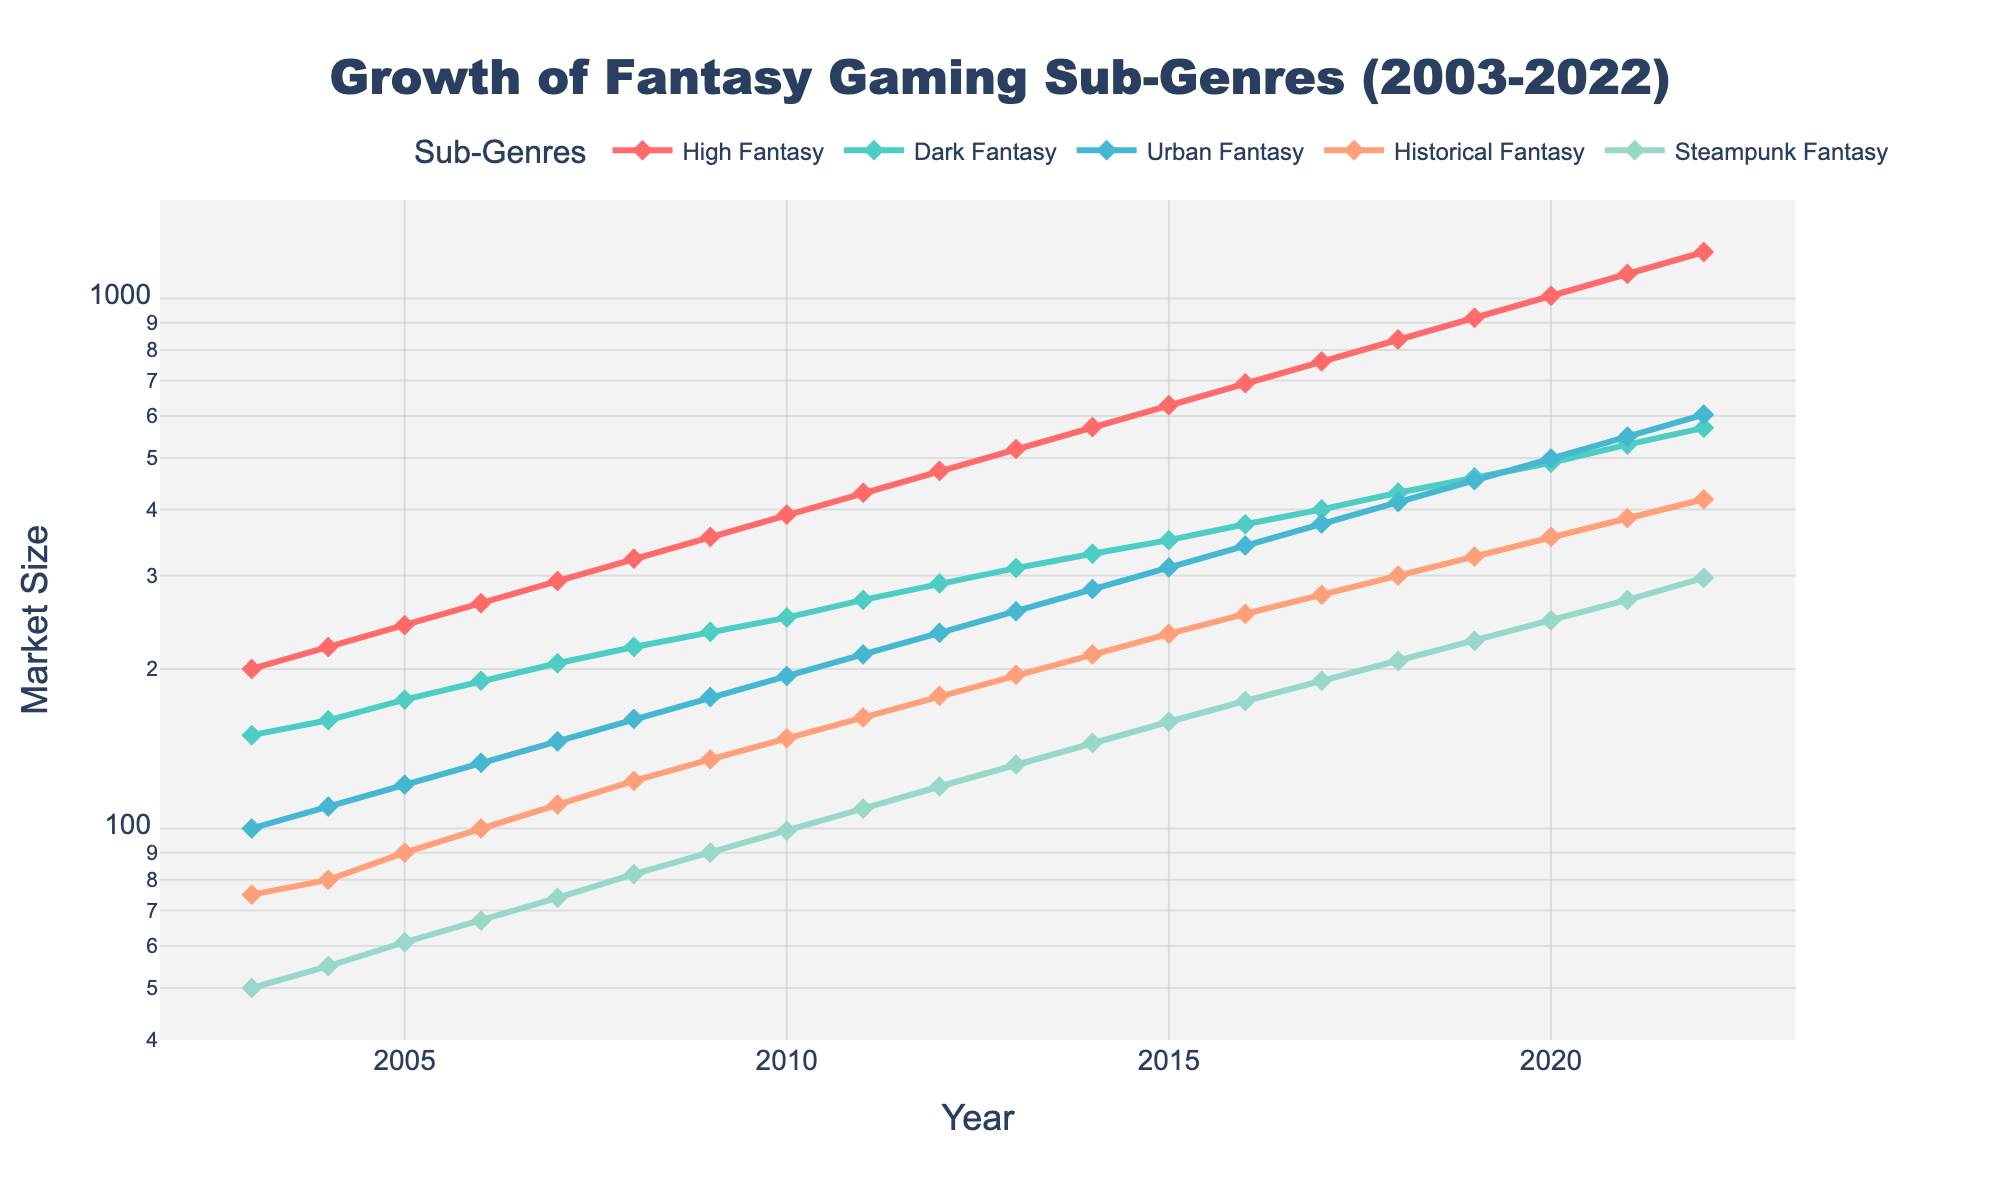What's the title of the plot? The title is located at the top center of the plot. It gives an overview of what the data represents. Here, it clearly states that the plot is about the growth of fantasy gaming sub-genres from 2003 to 2022.
Answer: "Growth of Fantasy Gaming Sub-Genres (2003-2022)" What are the sub-genres of fantasy games represented in the plot? The sub-genres are indicated by the different colored lines and are listed in the legend. This plot features High Fantasy, Dark Fantasy, Urban Fantasy, Historical Fantasy, and Steampunk Fantasy.
Answer: High Fantasy, Dark Fantasy, Urban Fantasy, Historical Fantasy, Steampunk Fantasy Which sub-genre had the highest market size in 2022? To find this, locate the year 2022 on the x-axis and check which line reaches the highest value on the y-axis. The High Fantasy line is at the top in 2022.
Answer: High Fantasy Between which years did Steampunk Fantasy show the most significant increase? Examine the trend of the Steampunk Fantasy line (light blue) over time. The most significant increase is identified by the steepest upward slope. The steepest rise appears between 2017 and 2022.
Answer: 2017-2022 By how much did the market size for Urban Fantasy grow between 2010 and 2020? Locate the market size for Urban Fantasy in 2010 and 2020 using their respective points on the purple line. In 2010, the market size was 194, and in 2020, it was 499. The growth is calculated by subtracting the 2010 value from the 2020 value (499 - 194).
Answer: 305 Which sub-genre had the slowest growth rate overall? Examine the overall trends of each line. The line with the least steep slope indicates the slowest growth. The Steampunk Fantasy line (light blue) has the shallowest slope compared to others.
Answer: Steampunk Fantasy How did the market size of Dark Fantasy compare to High Fantasy in 2015? Find the values of both sub-genres in 2015 by checking their respective lines. The Dark Fantasy line (green) is at 350, while the High Fantasy line (red) is at 629. High Fantasy's market size is larger than Dark Fantasy's.
Answer: High Fantasy > Dark Fantasy Which sub-genres had intersecting growth trends between 2006 and 2010? Look for intersections of lines between the years 2006 and 2010 on the x-axis. The Dark Fantasy (green) and Urban Fantasy (purple) lines intersect around 2009.
Answer: Dark Fantasy and Urban Fantasy What is the range of market sizes for Urban Fantasy in the plot? The range is determined by the minimum and maximum values of the Urban Fantasy line (purple) from 2003 to 2022. The values are approximately 100 (2003) and 604 (2022). The range is calculated by 604 - 100.
Answer: 504 